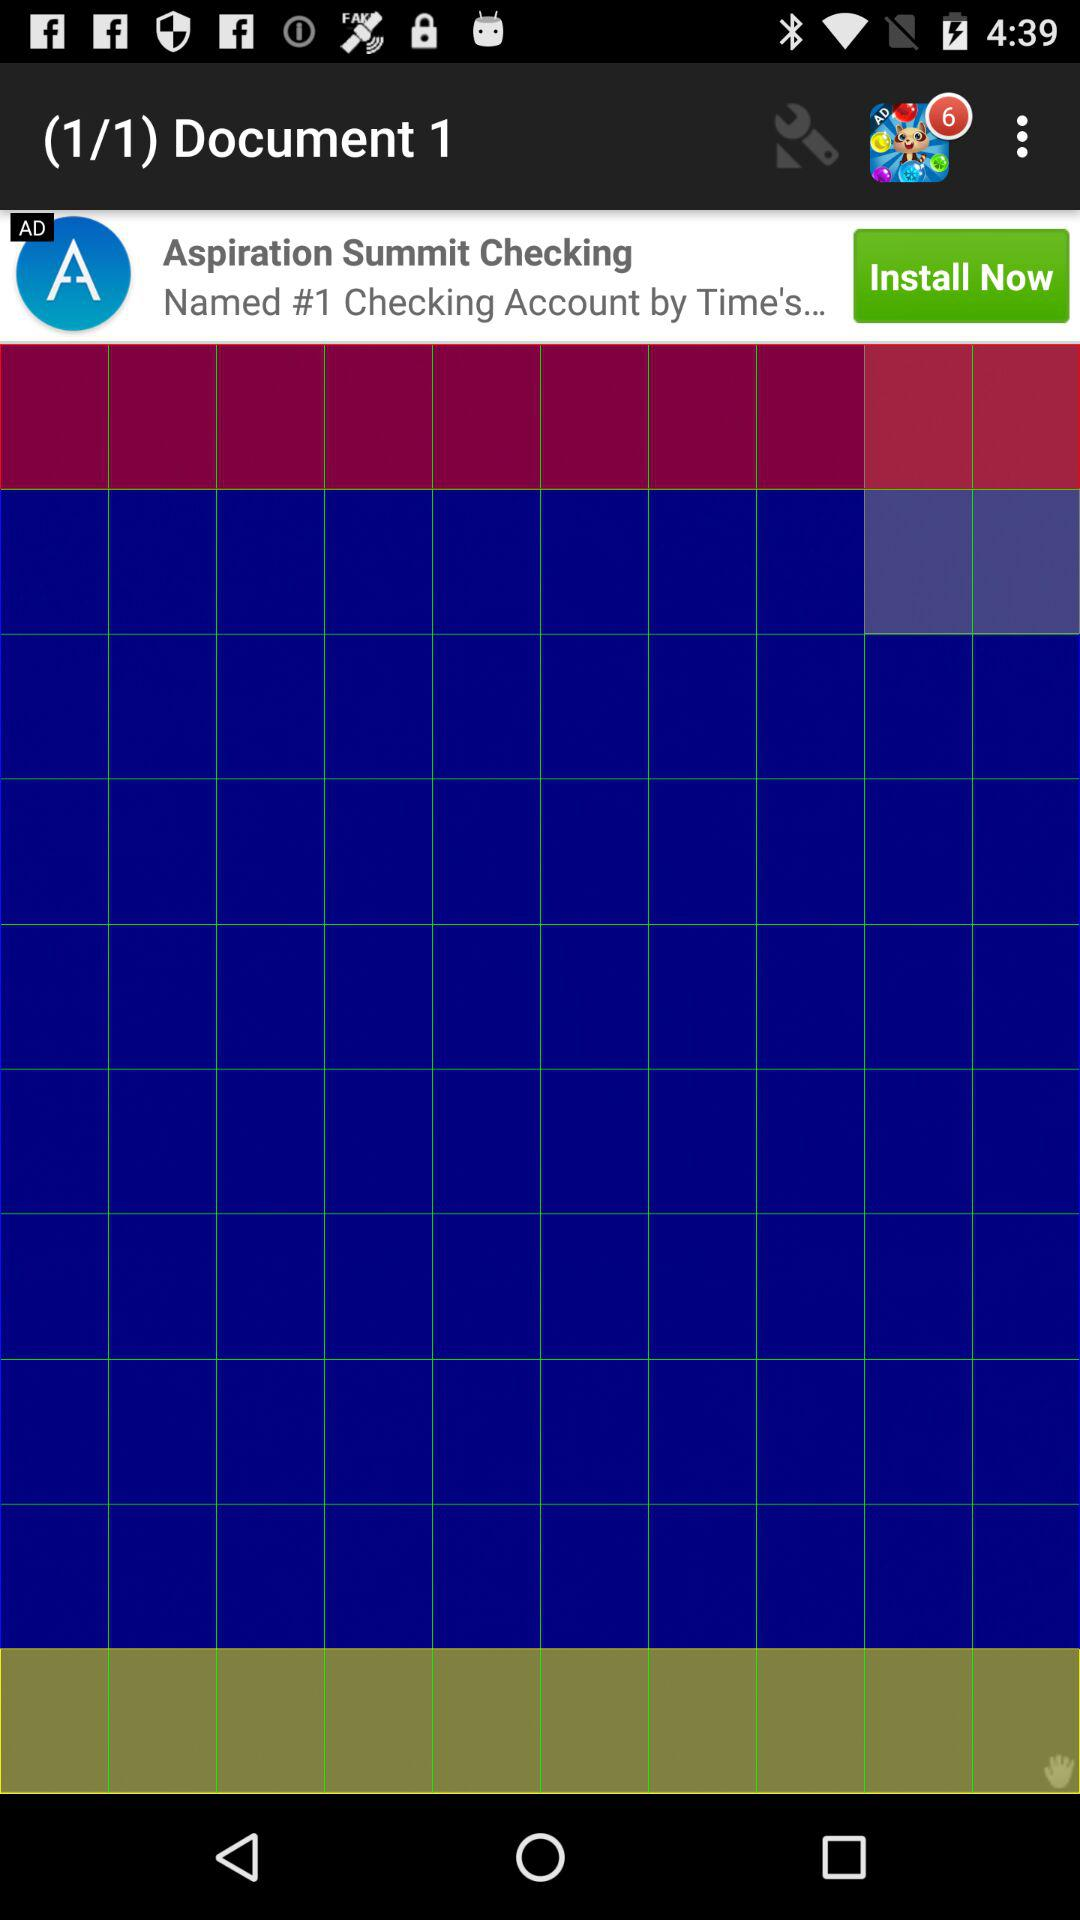How many documents are there in total? There is 1 document in total. 